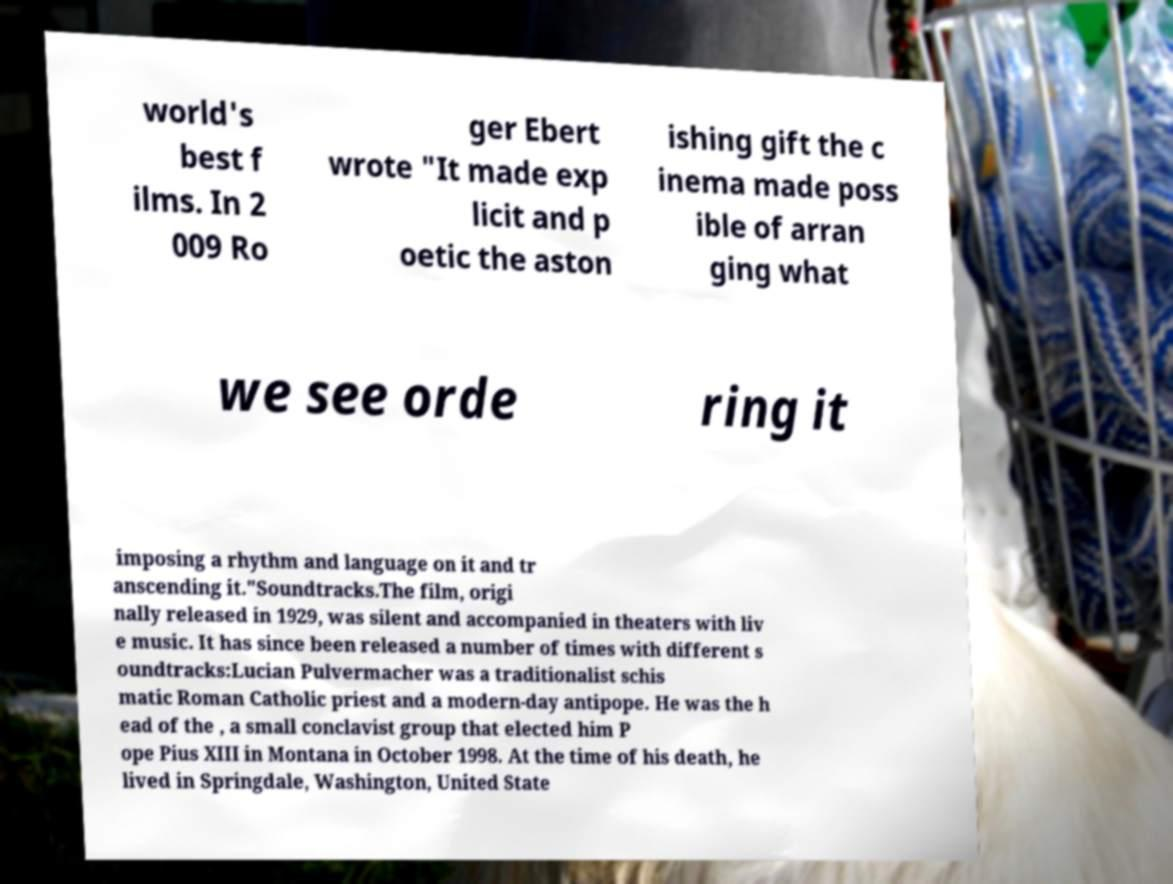What messages or text are displayed in this image? I need them in a readable, typed format. world's best f ilms. In 2 009 Ro ger Ebert wrote "It made exp licit and p oetic the aston ishing gift the c inema made poss ible of arran ging what we see orde ring it imposing a rhythm and language on it and tr anscending it."Soundtracks.The film, origi nally released in 1929, was silent and accompanied in theaters with liv e music. It has since been released a number of times with different s oundtracks:Lucian Pulvermacher was a traditionalist schis matic Roman Catholic priest and a modern-day antipope. He was the h ead of the , a small conclavist group that elected him P ope Pius XIII in Montana in October 1998. At the time of his death, he lived in Springdale, Washington, United State 